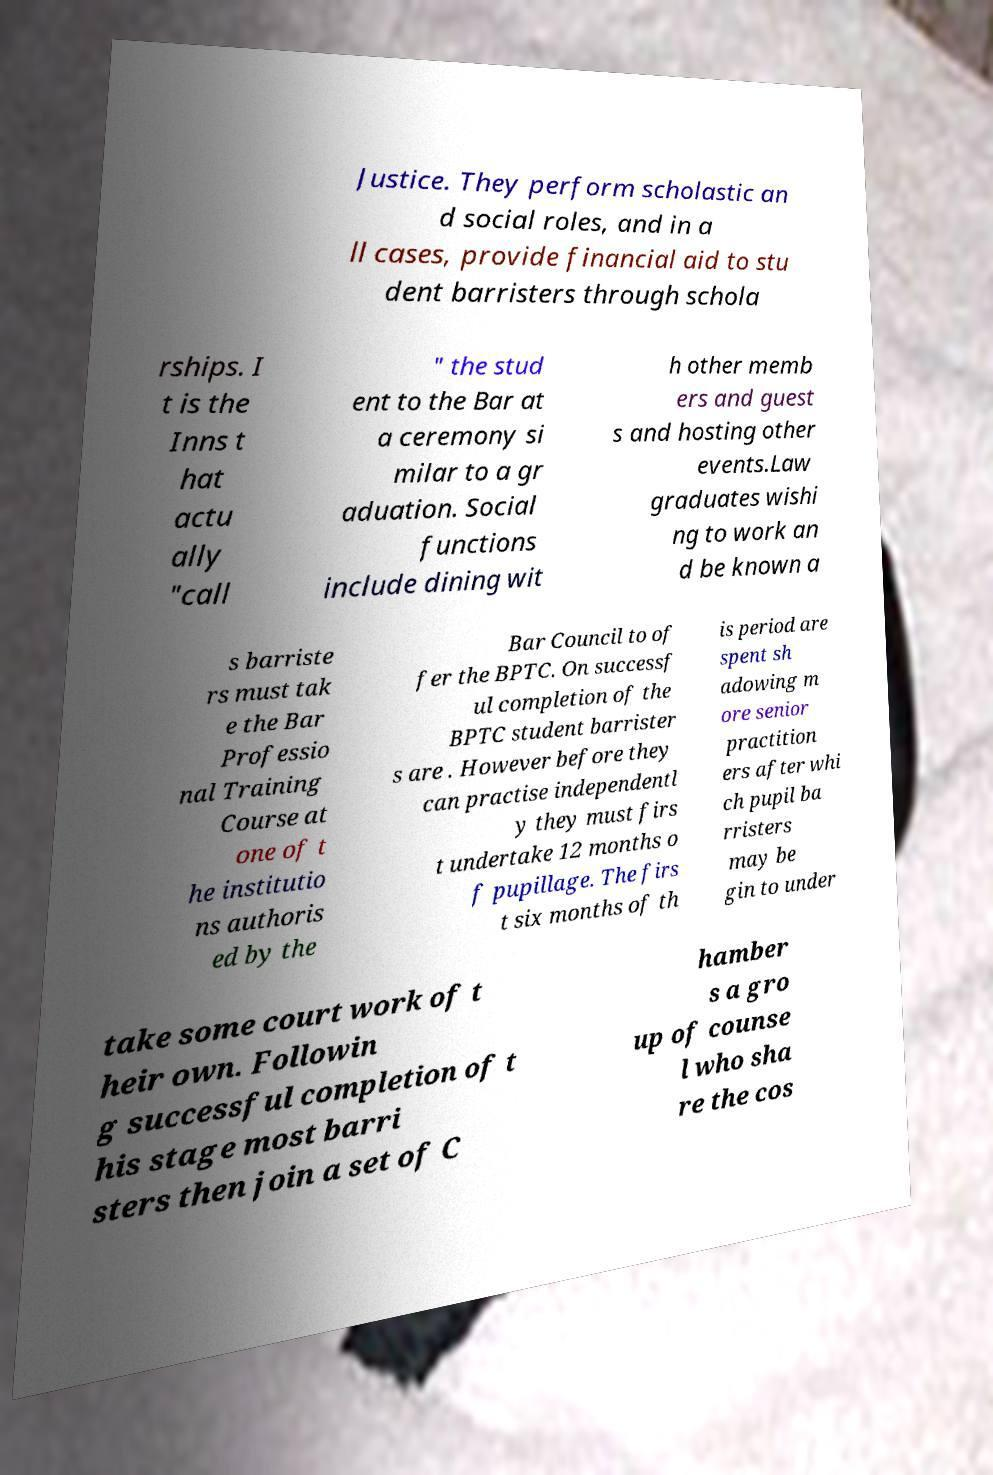Can you accurately transcribe the text from the provided image for me? Justice. They perform scholastic an d social roles, and in a ll cases, provide financial aid to stu dent barristers through schola rships. I t is the Inns t hat actu ally "call " the stud ent to the Bar at a ceremony si milar to a gr aduation. Social functions include dining wit h other memb ers and guest s and hosting other events.Law graduates wishi ng to work an d be known a s barriste rs must tak e the Bar Professio nal Training Course at one of t he institutio ns authoris ed by the Bar Council to of fer the BPTC. On successf ul completion of the BPTC student barrister s are . However before they can practise independentl y they must firs t undertake 12 months o f pupillage. The firs t six months of th is period are spent sh adowing m ore senior practition ers after whi ch pupil ba rristers may be gin to under take some court work of t heir own. Followin g successful completion of t his stage most barri sters then join a set of C hamber s a gro up of counse l who sha re the cos 